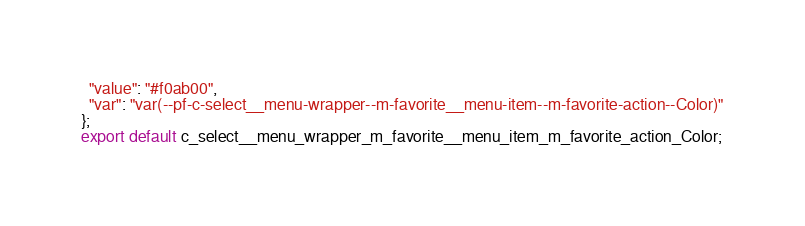Convert code to text. <code><loc_0><loc_0><loc_500><loc_500><_TypeScript_>  "value": "#f0ab00",
  "var": "var(--pf-c-select__menu-wrapper--m-favorite__menu-item--m-favorite-action--Color)"
};
export default c_select__menu_wrapper_m_favorite__menu_item_m_favorite_action_Color;</code> 